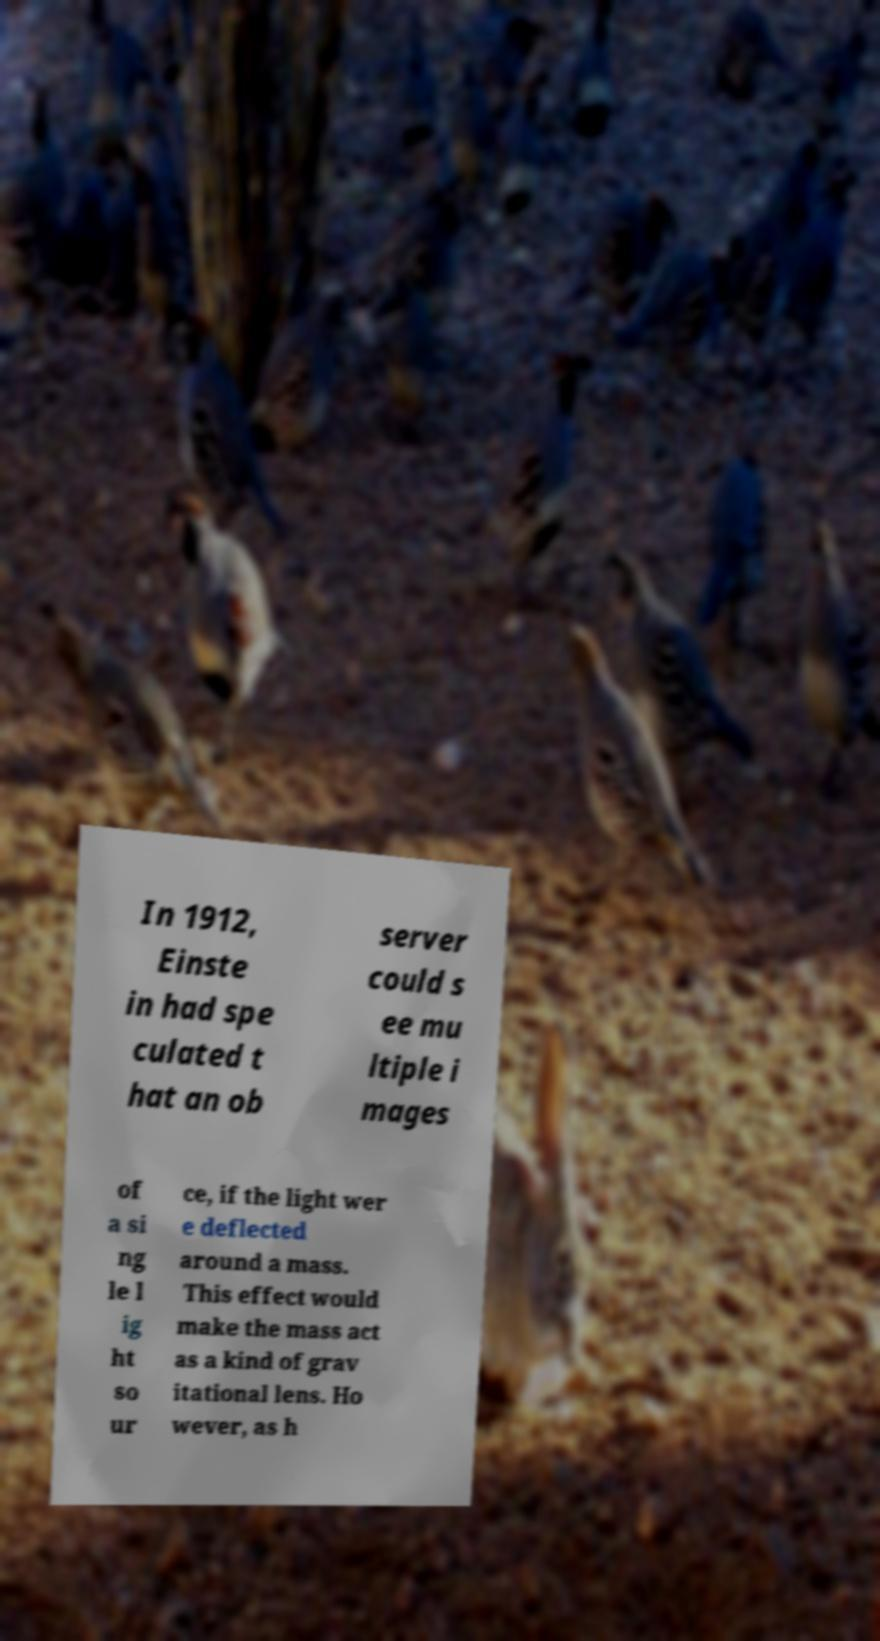Could you assist in decoding the text presented in this image and type it out clearly? In 1912, Einste in had spe culated t hat an ob server could s ee mu ltiple i mages of a si ng le l ig ht so ur ce, if the light wer e deflected around a mass. This effect would make the mass act as a kind of grav itational lens. Ho wever, as h 